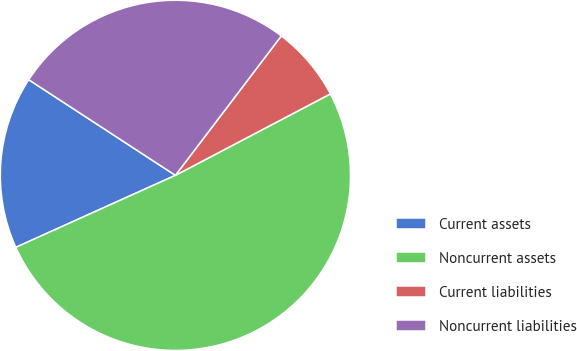Convert chart to OTSL. <chart><loc_0><loc_0><loc_500><loc_500><pie_chart><fcel>Current assets<fcel>Noncurrent assets<fcel>Current liabilities<fcel>Noncurrent liabilities<nl><fcel>15.94%<fcel>50.95%<fcel>6.96%<fcel>26.14%<nl></chart> 